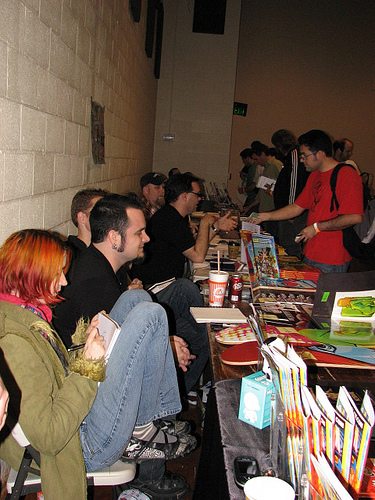<image>
Is there a man to the right of the table? Yes. From this viewpoint, the man is positioned to the right side relative to the table. Is there a wall in front of the male? Yes. The wall is positioned in front of the male, appearing closer to the camera viewpoint. 